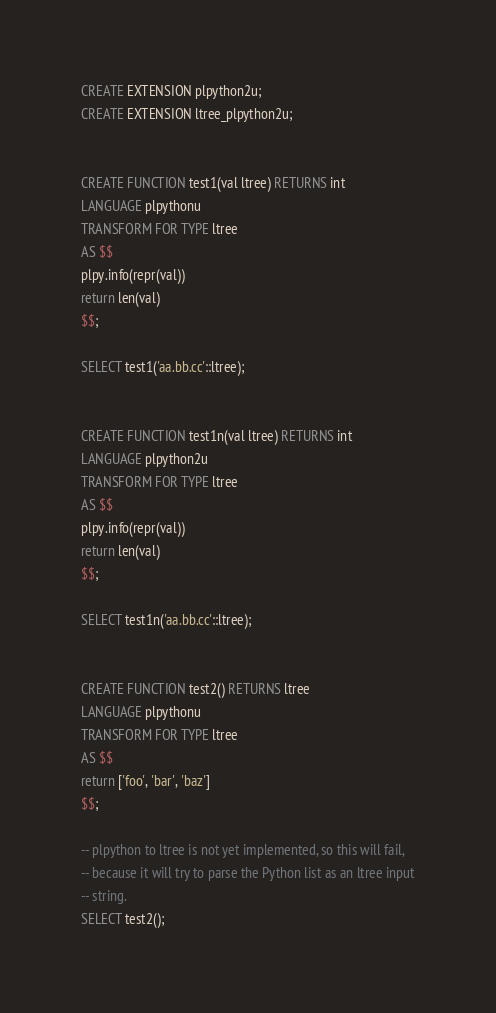<code> <loc_0><loc_0><loc_500><loc_500><_SQL_>CREATE EXTENSION plpython2u;
CREATE EXTENSION ltree_plpython2u;


CREATE FUNCTION test1(val ltree) RETURNS int
LANGUAGE plpythonu
TRANSFORM FOR TYPE ltree
AS $$
plpy.info(repr(val))
return len(val)
$$;

SELECT test1('aa.bb.cc'::ltree);


CREATE FUNCTION test1n(val ltree) RETURNS int
LANGUAGE plpython2u
TRANSFORM FOR TYPE ltree
AS $$
plpy.info(repr(val))
return len(val)
$$;

SELECT test1n('aa.bb.cc'::ltree);


CREATE FUNCTION test2() RETURNS ltree
LANGUAGE plpythonu
TRANSFORM FOR TYPE ltree
AS $$
return ['foo', 'bar', 'baz']
$$;

-- plpython to ltree is not yet implemented, so this will fail,
-- because it will try to parse the Python list as an ltree input
-- string.
SELECT test2();
</code> 